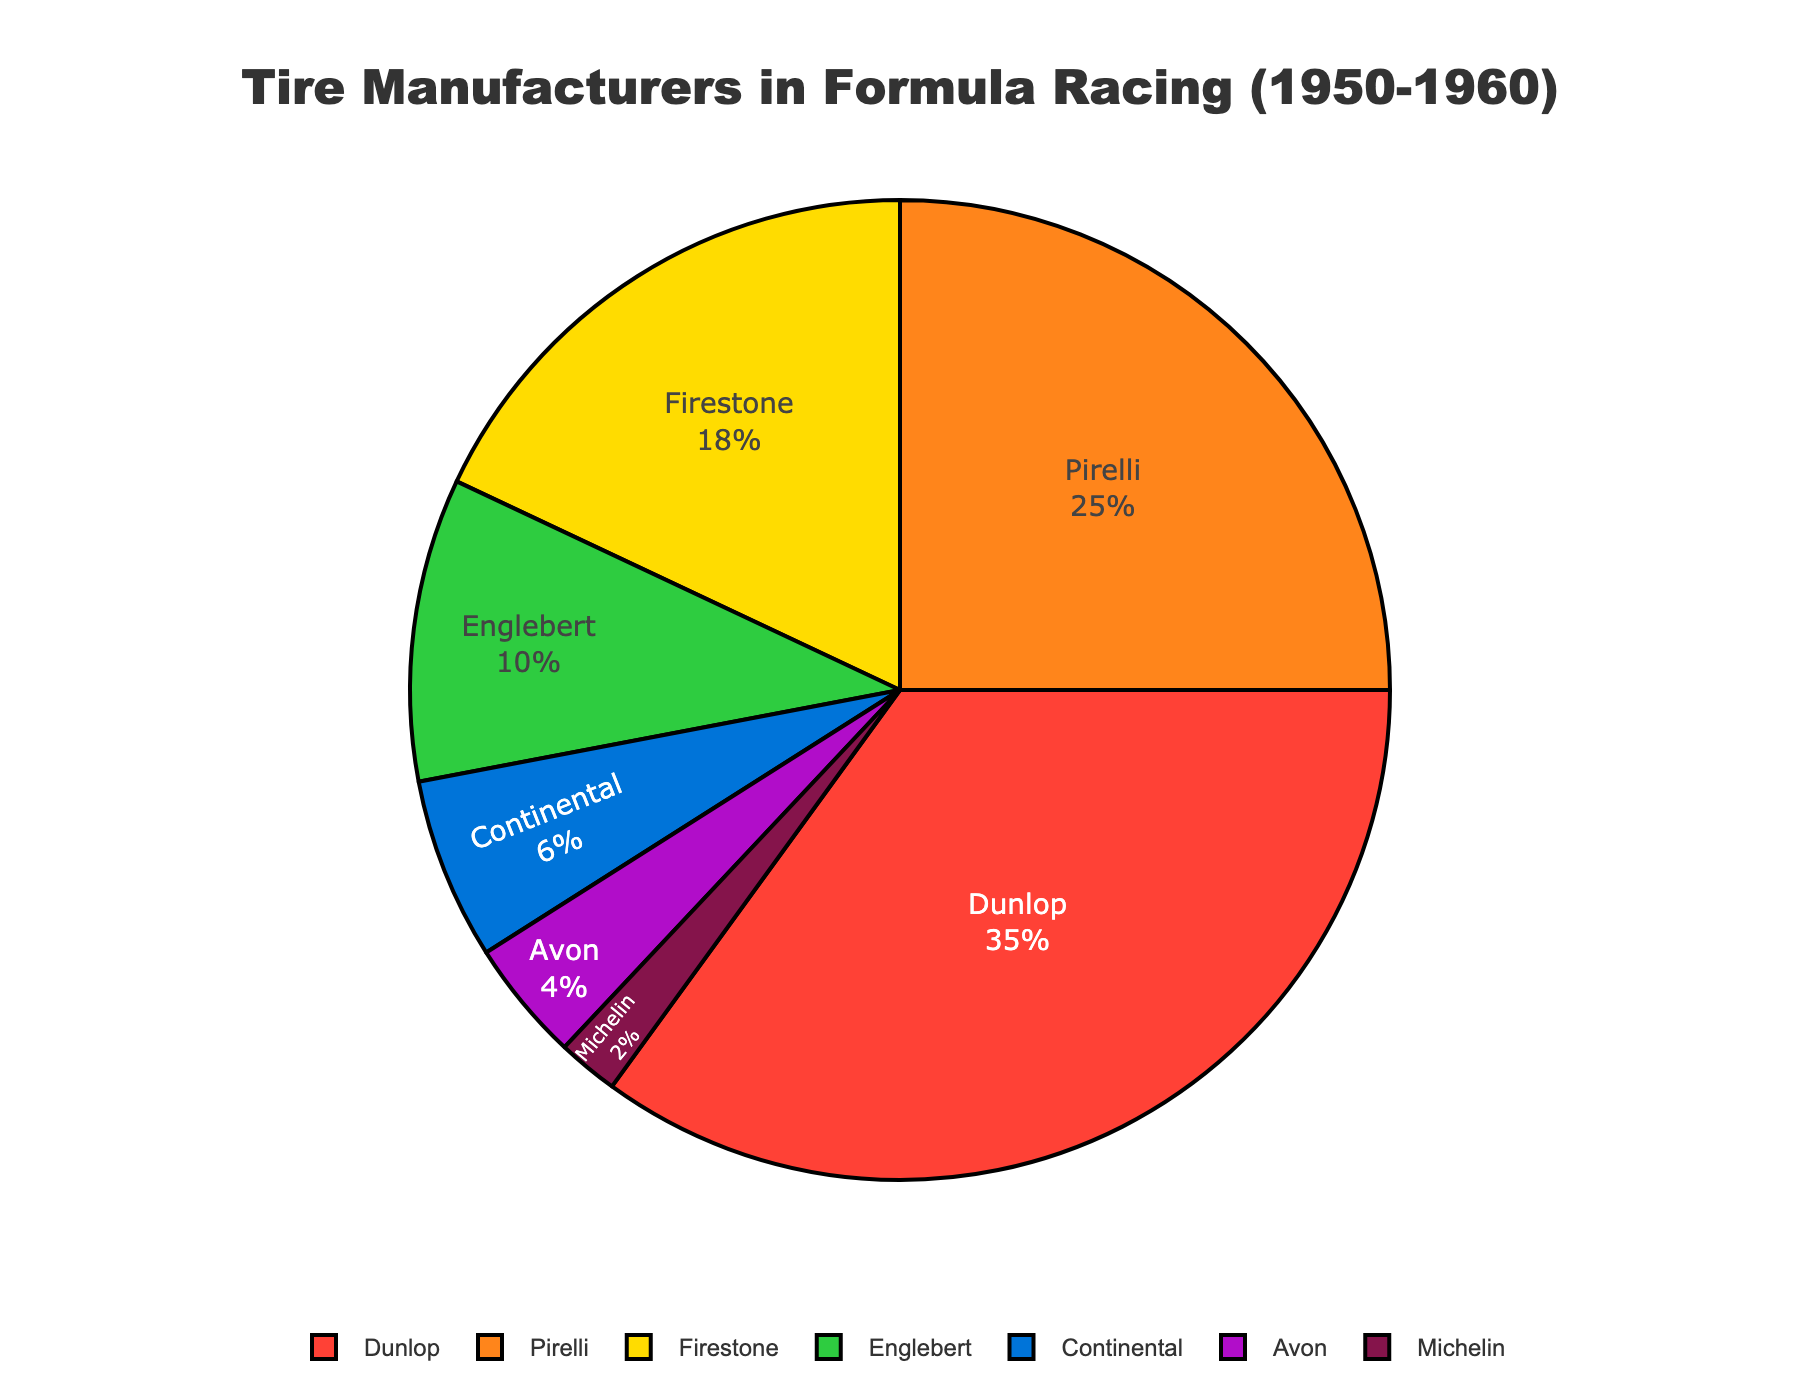Which manufacturer supplied the most tires? Dunlop has the highest percentage in the pie chart with 35%.
Answer: Dunlop Which manufacturer has the smallest market share? Michelin has the smallest slice in the pie chart, representing only 2%.
Answer: Michelin What's the combined market share of Continental and Avon? The sum of Continental's 6% and Avon's 4% equals 10%.
Answer: 10% What's the difference in market share between Dunlop and Firestone? Dunlop has 35% and Firestone has 18%; the difference is 35% - 18% = 17%.
Answer: 17% Which two manufacturers together account for exactly half of the market? Dunlop (35%) and Pirelli (25%) together account for 60%, not 50%. Firestone (18%) and Englebert (10%) together account for 28%, which is not 50%. The correct combination must be computed step by step.
Answer: Dunlop and Pirelli How many manufacturers have a market share less than 10%? Englebert (10%), Continental (6%), Avon (4%), and Michelin (2%) all have less than 10%.
Answer: 4 What's the total market share of manufacturers excluding Dunlop and Pirelli? Subtracting Dunlop (35%) and Pirelli (25%) from the total, 100% - 35% - 25% = 40%.
Answer: 40% What percentage of the market do the bottom three manufacturers represent? The shares of Avon, Continental and Michelin are added: 4% + 6% + 2% = 12%.
Answer: 12% Is the combined market share of Avon and Firestone greater than that of Pirelli? Avon (4%) and Firestone (18%) together make 22%, which is less than Pirelli's 25%.
Answer: No Which manufacturer accounts for twice the market share of Englebert? Englebert has 10%; double that is 20%. No single manufacturer has exactly 20%, but Dunlop has 35% and Firestone has 18%.
Answer: None 